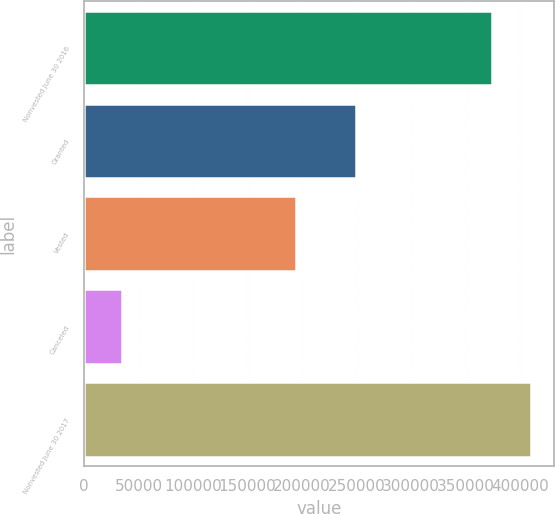Convert chart to OTSL. <chart><loc_0><loc_0><loc_500><loc_500><bar_chart><fcel>Nonvested June 30 2016<fcel>Granted<fcel>Vested<fcel>Canceled<fcel>Nonvested June 30 2017<nl><fcel>374168<fcel>249892<fcel>194844<fcel>34887<fcel>410112<nl></chart> 